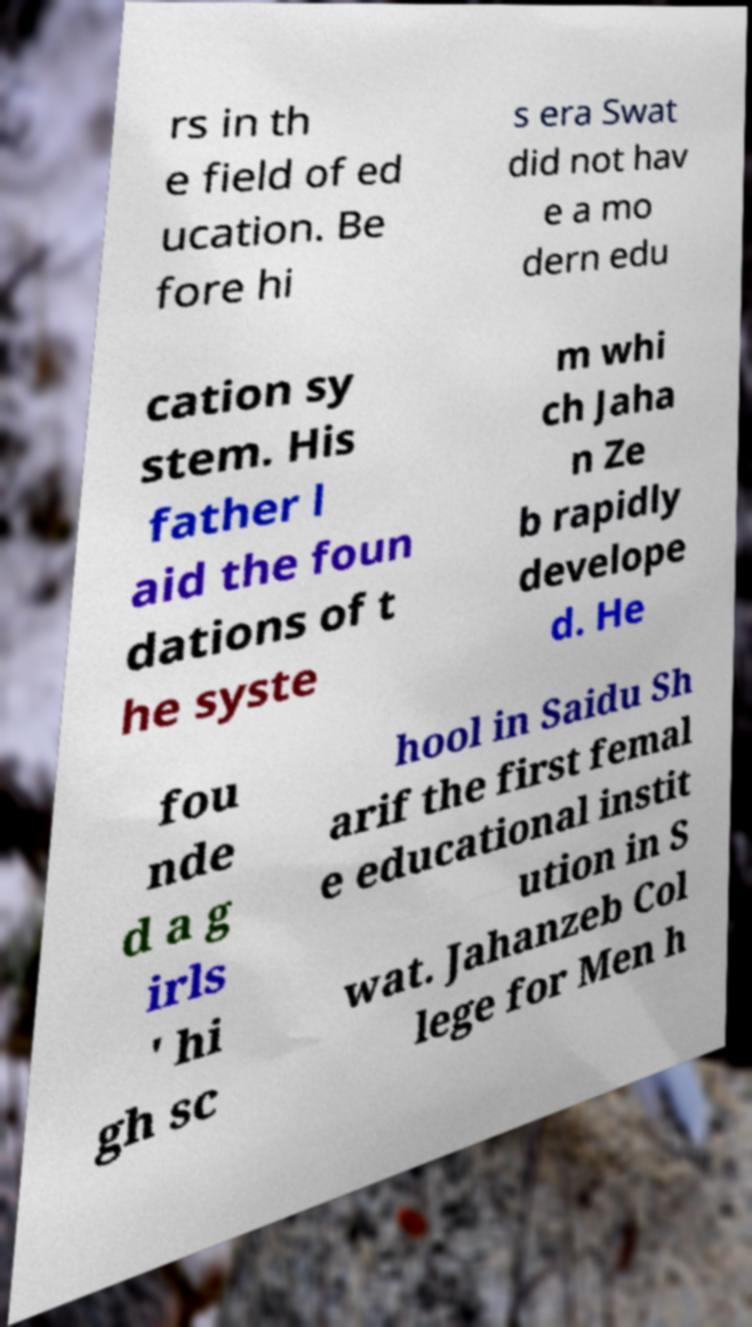Please read and relay the text visible in this image. What does it say? rs in th e field of ed ucation. Be fore hi s era Swat did not hav e a mo dern edu cation sy stem. His father l aid the foun dations of t he syste m whi ch Jaha n Ze b rapidly develope d. He fou nde d a g irls ' hi gh sc hool in Saidu Sh arif the first femal e educational instit ution in S wat. Jahanzeb Col lege for Men h 